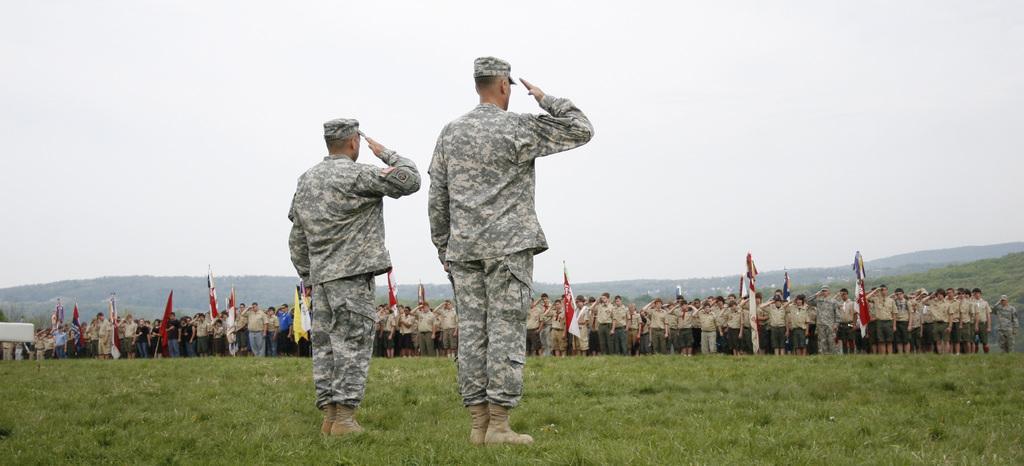Could you give a brief overview of what you see in this image? As we can see in the image there is a clear and in front there are two army people, army men are standing and they are saluting in front of the army men there is a big gathering of the men and they are saluting. The ground is covered with grass and the gathering is holding the flags in their hands. 